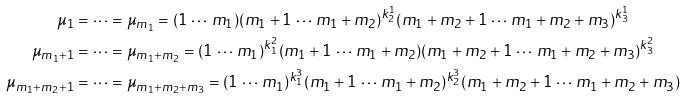<formula> <loc_0><loc_0><loc_500><loc_500>\mu _ { 1 } & = \dots = \mu _ { m _ { 1 } } = ( 1 \, \cdots \, m _ { 1 } ) ( m _ { 1 } + 1 \, \cdots \, m _ { 1 } + m _ { 2 } ) ^ { k _ { 2 } ^ { 1 } } ( m _ { 1 } + m _ { 2 } + 1 \, \cdots \, m _ { 1 } + m _ { 2 } + m _ { 3 } ) ^ { k _ { 3 } ^ { 1 } } \\ \mu _ { m _ { 1 } + 1 } & = \cdots = \mu _ { m _ { 1 } + m _ { 2 } } = ( 1 \, \cdots \, m _ { 1 } ) ^ { k _ { 1 } ^ { 2 } } ( m _ { 1 } + 1 \, \cdots \, m _ { 1 } + m _ { 2 } ) ( m _ { 1 } + m _ { 2 } + 1 \, \cdots \, m _ { 1 } + m _ { 2 } + m _ { 3 } ) ^ { k _ { 3 } ^ { 2 } } \\ \mu _ { m _ { 1 } + m _ { 2 } + 1 } & = \dots = \mu _ { m _ { 1 } + m _ { 2 } + m _ { 3 } } = ( 1 \, \cdots \, m _ { 1 } ) ^ { k _ { 1 } ^ { 3 } } ( m _ { 1 } + 1 \, \cdots \, m _ { 1 } + m _ { 2 } ) ^ { k _ { 2 } ^ { 3 } } ( m _ { 1 } + m _ { 2 } + 1 \, \cdots \, m _ { 1 } + m _ { 2 } + m _ { 3 } )</formula> 